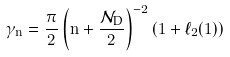<formula> <loc_0><loc_0><loc_500><loc_500>\gamma _ { n } = \frac { \pi } { 2 } \left ( n + \frac { \mathcal { N } _ { \text {D} } } { 2 } \right ) ^ { - 2 } \left ( 1 + \ell _ { 2 } ( 1 ) \right )</formula> 